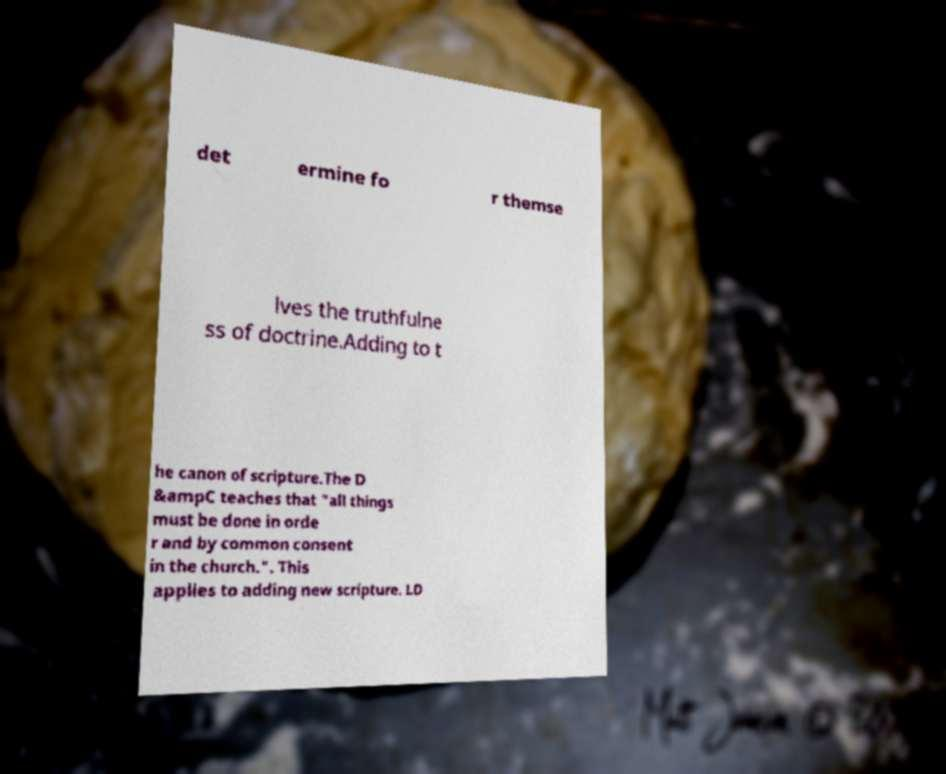Please identify and transcribe the text found in this image. det ermine fo r themse lves the truthfulne ss of doctrine.Adding to t he canon of scripture.The D &ampC teaches that "all things must be done in orde r and by common consent in the church.". This applies to adding new scripture. LD 